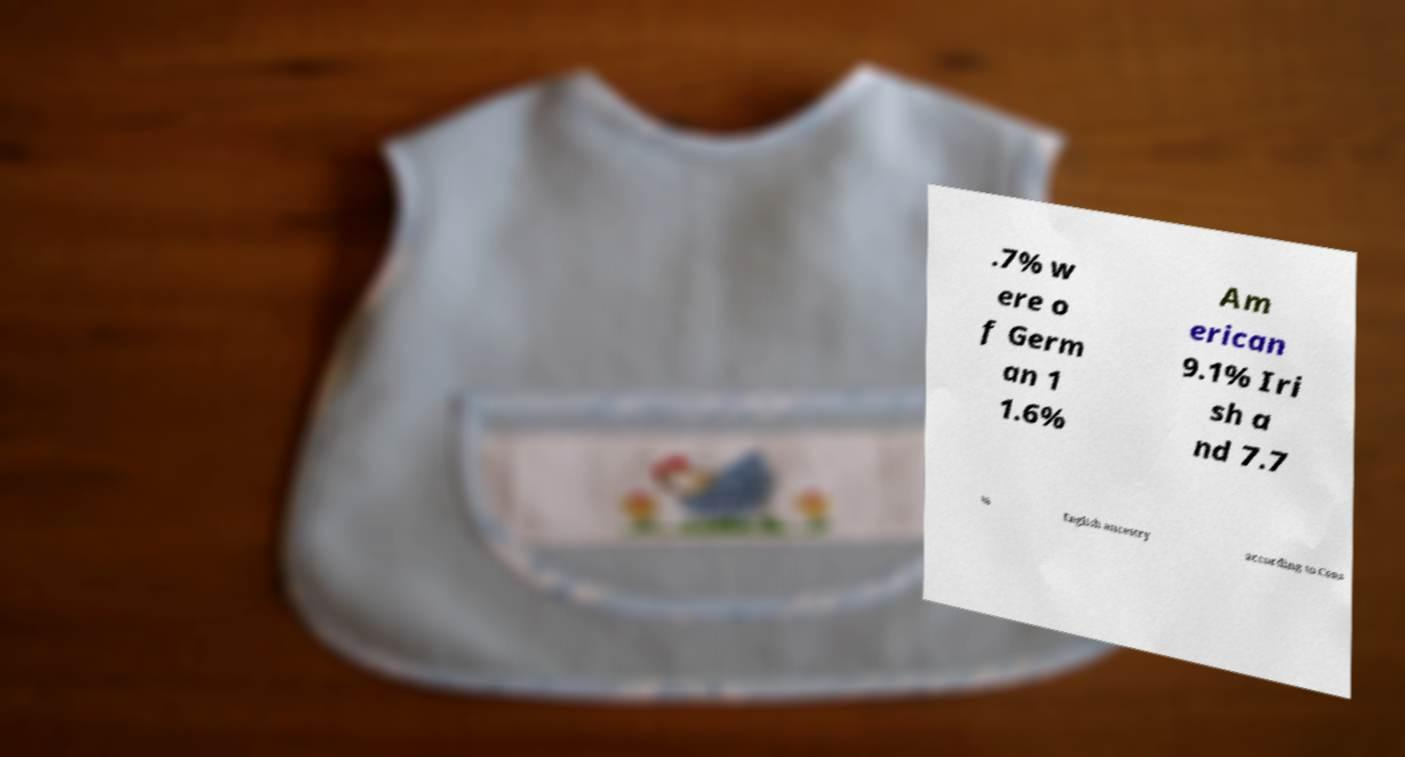I need the written content from this picture converted into text. Can you do that? .7% w ere o f Germ an 1 1.6% Am erican 9.1% Iri sh a nd 7.7 % English ancestry according to Cens 